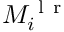<formula> <loc_0><loc_0><loc_500><loc_500>M _ { i } ^ { l r }</formula> 